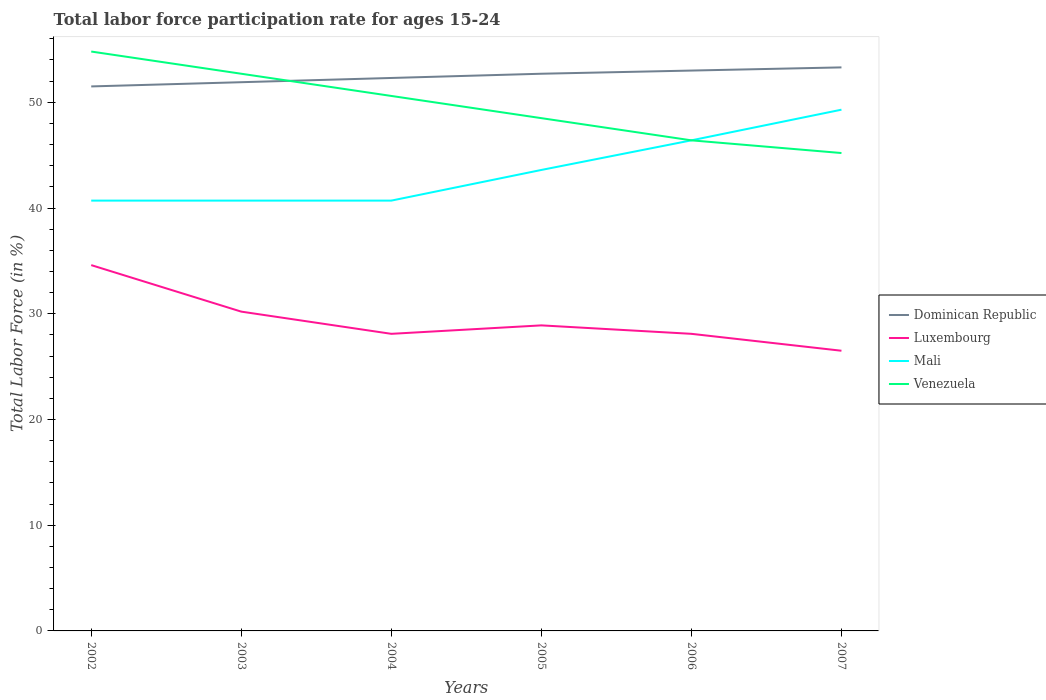Does the line corresponding to Luxembourg intersect with the line corresponding to Mali?
Make the answer very short. No. Across all years, what is the maximum labor force participation rate in Mali?
Offer a terse response. 40.7. In which year was the labor force participation rate in Mali maximum?
Offer a terse response. 2002. What is the total labor force participation rate in Dominican Republic in the graph?
Your response must be concise. -1.4. What is the difference between the highest and the second highest labor force participation rate in Dominican Republic?
Your response must be concise. 1.8. What is the difference between the highest and the lowest labor force participation rate in Mali?
Your answer should be compact. 3. How many lines are there?
Offer a very short reply. 4. How many years are there in the graph?
Offer a very short reply. 6. What is the difference between two consecutive major ticks on the Y-axis?
Your answer should be compact. 10. Are the values on the major ticks of Y-axis written in scientific E-notation?
Provide a succinct answer. No. Does the graph contain any zero values?
Offer a very short reply. No. Does the graph contain grids?
Give a very brief answer. No. Where does the legend appear in the graph?
Your response must be concise. Center right. How many legend labels are there?
Provide a succinct answer. 4. How are the legend labels stacked?
Give a very brief answer. Vertical. What is the title of the graph?
Your answer should be very brief. Total labor force participation rate for ages 15-24. Does "Uganda" appear as one of the legend labels in the graph?
Make the answer very short. No. What is the Total Labor Force (in %) of Dominican Republic in 2002?
Your answer should be compact. 51.5. What is the Total Labor Force (in %) in Luxembourg in 2002?
Your answer should be compact. 34.6. What is the Total Labor Force (in %) in Mali in 2002?
Give a very brief answer. 40.7. What is the Total Labor Force (in %) of Venezuela in 2002?
Offer a very short reply. 54.8. What is the Total Labor Force (in %) of Dominican Republic in 2003?
Provide a succinct answer. 51.9. What is the Total Labor Force (in %) in Luxembourg in 2003?
Offer a very short reply. 30.2. What is the Total Labor Force (in %) in Mali in 2003?
Ensure brevity in your answer.  40.7. What is the Total Labor Force (in %) in Venezuela in 2003?
Keep it short and to the point. 52.7. What is the Total Labor Force (in %) of Dominican Republic in 2004?
Make the answer very short. 52.3. What is the Total Labor Force (in %) in Luxembourg in 2004?
Your answer should be very brief. 28.1. What is the Total Labor Force (in %) in Mali in 2004?
Offer a terse response. 40.7. What is the Total Labor Force (in %) in Venezuela in 2004?
Give a very brief answer. 50.6. What is the Total Labor Force (in %) in Dominican Republic in 2005?
Your answer should be compact. 52.7. What is the Total Labor Force (in %) of Luxembourg in 2005?
Your response must be concise. 28.9. What is the Total Labor Force (in %) in Mali in 2005?
Your response must be concise. 43.6. What is the Total Labor Force (in %) of Venezuela in 2005?
Keep it short and to the point. 48.5. What is the Total Labor Force (in %) in Luxembourg in 2006?
Your answer should be very brief. 28.1. What is the Total Labor Force (in %) of Mali in 2006?
Make the answer very short. 46.4. What is the Total Labor Force (in %) of Venezuela in 2006?
Make the answer very short. 46.4. What is the Total Labor Force (in %) in Dominican Republic in 2007?
Your answer should be very brief. 53.3. What is the Total Labor Force (in %) of Luxembourg in 2007?
Provide a succinct answer. 26.5. What is the Total Labor Force (in %) in Mali in 2007?
Ensure brevity in your answer.  49.3. What is the Total Labor Force (in %) in Venezuela in 2007?
Keep it short and to the point. 45.2. Across all years, what is the maximum Total Labor Force (in %) in Dominican Republic?
Provide a succinct answer. 53.3. Across all years, what is the maximum Total Labor Force (in %) in Luxembourg?
Your answer should be very brief. 34.6. Across all years, what is the maximum Total Labor Force (in %) in Mali?
Provide a succinct answer. 49.3. Across all years, what is the maximum Total Labor Force (in %) in Venezuela?
Keep it short and to the point. 54.8. Across all years, what is the minimum Total Labor Force (in %) in Dominican Republic?
Give a very brief answer. 51.5. Across all years, what is the minimum Total Labor Force (in %) in Mali?
Your answer should be compact. 40.7. Across all years, what is the minimum Total Labor Force (in %) of Venezuela?
Make the answer very short. 45.2. What is the total Total Labor Force (in %) in Dominican Republic in the graph?
Keep it short and to the point. 314.7. What is the total Total Labor Force (in %) of Luxembourg in the graph?
Offer a terse response. 176.4. What is the total Total Labor Force (in %) of Mali in the graph?
Offer a very short reply. 261.4. What is the total Total Labor Force (in %) of Venezuela in the graph?
Provide a short and direct response. 298.2. What is the difference between the Total Labor Force (in %) in Dominican Republic in 2002 and that in 2003?
Your answer should be compact. -0.4. What is the difference between the Total Labor Force (in %) of Mali in 2002 and that in 2003?
Give a very brief answer. 0. What is the difference between the Total Labor Force (in %) of Venezuela in 2002 and that in 2003?
Provide a short and direct response. 2.1. What is the difference between the Total Labor Force (in %) in Luxembourg in 2002 and that in 2004?
Your answer should be very brief. 6.5. What is the difference between the Total Labor Force (in %) of Dominican Republic in 2002 and that in 2005?
Offer a very short reply. -1.2. What is the difference between the Total Labor Force (in %) in Luxembourg in 2002 and that in 2005?
Your answer should be very brief. 5.7. What is the difference between the Total Labor Force (in %) of Dominican Republic in 2002 and that in 2006?
Give a very brief answer. -1.5. What is the difference between the Total Labor Force (in %) in Luxembourg in 2002 and that in 2006?
Ensure brevity in your answer.  6.5. What is the difference between the Total Labor Force (in %) of Mali in 2002 and that in 2006?
Your answer should be compact. -5.7. What is the difference between the Total Labor Force (in %) in Luxembourg in 2002 and that in 2007?
Your answer should be compact. 8.1. What is the difference between the Total Labor Force (in %) in Mali in 2002 and that in 2007?
Your answer should be compact. -8.6. What is the difference between the Total Labor Force (in %) in Venezuela in 2002 and that in 2007?
Offer a very short reply. 9.6. What is the difference between the Total Labor Force (in %) of Luxembourg in 2003 and that in 2004?
Ensure brevity in your answer.  2.1. What is the difference between the Total Labor Force (in %) of Mali in 2003 and that in 2004?
Provide a short and direct response. 0. What is the difference between the Total Labor Force (in %) of Dominican Republic in 2003 and that in 2005?
Your response must be concise. -0.8. What is the difference between the Total Labor Force (in %) of Luxembourg in 2003 and that in 2005?
Give a very brief answer. 1.3. What is the difference between the Total Labor Force (in %) of Mali in 2003 and that in 2005?
Give a very brief answer. -2.9. What is the difference between the Total Labor Force (in %) in Dominican Republic in 2003 and that in 2006?
Provide a succinct answer. -1.1. What is the difference between the Total Labor Force (in %) of Mali in 2003 and that in 2006?
Provide a succinct answer. -5.7. What is the difference between the Total Labor Force (in %) of Venezuela in 2003 and that in 2006?
Make the answer very short. 6.3. What is the difference between the Total Labor Force (in %) in Dominican Republic in 2003 and that in 2007?
Your answer should be very brief. -1.4. What is the difference between the Total Labor Force (in %) of Mali in 2003 and that in 2007?
Provide a succinct answer. -8.6. What is the difference between the Total Labor Force (in %) of Venezuela in 2003 and that in 2007?
Keep it short and to the point. 7.5. What is the difference between the Total Labor Force (in %) in Dominican Republic in 2004 and that in 2005?
Provide a short and direct response. -0.4. What is the difference between the Total Labor Force (in %) of Mali in 2004 and that in 2005?
Your answer should be very brief. -2.9. What is the difference between the Total Labor Force (in %) in Dominican Republic in 2004 and that in 2006?
Make the answer very short. -0.7. What is the difference between the Total Labor Force (in %) in Mali in 2004 and that in 2006?
Provide a succinct answer. -5.7. What is the difference between the Total Labor Force (in %) of Venezuela in 2004 and that in 2006?
Make the answer very short. 4.2. What is the difference between the Total Labor Force (in %) in Dominican Republic in 2004 and that in 2007?
Your answer should be very brief. -1. What is the difference between the Total Labor Force (in %) in Dominican Republic in 2005 and that in 2006?
Offer a very short reply. -0.3. What is the difference between the Total Labor Force (in %) in Venezuela in 2005 and that in 2006?
Provide a succinct answer. 2.1. What is the difference between the Total Labor Force (in %) of Luxembourg in 2005 and that in 2007?
Your answer should be compact. 2.4. What is the difference between the Total Labor Force (in %) of Mali in 2005 and that in 2007?
Offer a very short reply. -5.7. What is the difference between the Total Labor Force (in %) of Dominican Republic in 2006 and that in 2007?
Provide a short and direct response. -0.3. What is the difference between the Total Labor Force (in %) of Mali in 2006 and that in 2007?
Offer a very short reply. -2.9. What is the difference between the Total Labor Force (in %) in Dominican Republic in 2002 and the Total Labor Force (in %) in Luxembourg in 2003?
Offer a very short reply. 21.3. What is the difference between the Total Labor Force (in %) of Dominican Republic in 2002 and the Total Labor Force (in %) of Mali in 2003?
Your answer should be compact. 10.8. What is the difference between the Total Labor Force (in %) in Luxembourg in 2002 and the Total Labor Force (in %) in Mali in 2003?
Make the answer very short. -6.1. What is the difference between the Total Labor Force (in %) of Luxembourg in 2002 and the Total Labor Force (in %) of Venezuela in 2003?
Your answer should be compact. -18.1. What is the difference between the Total Labor Force (in %) of Mali in 2002 and the Total Labor Force (in %) of Venezuela in 2003?
Offer a very short reply. -12. What is the difference between the Total Labor Force (in %) of Dominican Republic in 2002 and the Total Labor Force (in %) of Luxembourg in 2004?
Make the answer very short. 23.4. What is the difference between the Total Labor Force (in %) of Dominican Republic in 2002 and the Total Labor Force (in %) of Venezuela in 2004?
Your response must be concise. 0.9. What is the difference between the Total Labor Force (in %) of Dominican Republic in 2002 and the Total Labor Force (in %) of Luxembourg in 2005?
Your answer should be compact. 22.6. What is the difference between the Total Labor Force (in %) of Dominican Republic in 2002 and the Total Labor Force (in %) of Venezuela in 2005?
Your answer should be very brief. 3. What is the difference between the Total Labor Force (in %) in Luxembourg in 2002 and the Total Labor Force (in %) in Mali in 2005?
Keep it short and to the point. -9. What is the difference between the Total Labor Force (in %) in Luxembourg in 2002 and the Total Labor Force (in %) in Venezuela in 2005?
Your response must be concise. -13.9. What is the difference between the Total Labor Force (in %) of Mali in 2002 and the Total Labor Force (in %) of Venezuela in 2005?
Keep it short and to the point. -7.8. What is the difference between the Total Labor Force (in %) in Dominican Republic in 2002 and the Total Labor Force (in %) in Luxembourg in 2006?
Offer a very short reply. 23.4. What is the difference between the Total Labor Force (in %) of Dominican Republic in 2002 and the Total Labor Force (in %) of Mali in 2006?
Make the answer very short. 5.1. What is the difference between the Total Labor Force (in %) in Dominican Republic in 2002 and the Total Labor Force (in %) in Venezuela in 2006?
Your answer should be compact. 5.1. What is the difference between the Total Labor Force (in %) in Mali in 2002 and the Total Labor Force (in %) in Venezuela in 2006?
Your answer should be very brief. -5.7. What is the difference between the Total Labor Force (in %) in Luxembourg in 2002 and the Total Labor Force (in %) in Mali in 2007?
Your response must be concise. -14.7. What is the difference between the Total Labor Force (in %) of Luxembourg in 2002 and the Total Labor Force (in %) of Venezuela in 2007?
Offer a terse response. -10.6. What is the difference between the Total Labor Force (in %) of Mali in 2002 and the Total Labor Force (in %) of Venezuela in 2007?
Your answer should be very brief. -4.5. What is the difference between the Total Labor Force (in %) of Dominican Republic in 2003 and the Total Labor Force (in %) of Luxembourg in 2004?
Ensure brevity in your answer.  23.8. What is the difference between the Total Labor Force (in %) in Dominican Republic in 2003 and the Total Labor Force (in %) in Mali in 2004?
Your response must be concise. 11.2. What is the difference between the Total Labor Force (in %) of Luxembourg in 2003 and the Total Labor Force (in %) of Mali in 2004?
Offer a very short reply. -10.5. What is the difference between the Total Labor Force (in %) of Luxembourg in 2003 and the Total Labor Force (in %) of Venezuela in 2004?
Your answer should be compact. -20.4. What is the difference between the Total Labor Force (in %) in Mali in 2003 and the Total Labor Force (in %) in Venezuela in 2004?
Your answer should be compact. -9.9. What is the difference between the Total Labor Force (in %) in Dominican Republic in 2003 and the Total Labor Force (in %) in Mali in 2005?
Give a very brief answer. 8.3. What is the difference between the Total Labor Force (in %) in Luxembourg in 2003 and the Total Labor Force (in %) in Mali in 2005?
Give a very brief answer. -13.4. What is the difference between the Total Labor Force (in %) of Luxembourg in 2003 and the Total Labor Force (in %) of Venezuela in 2005?
Ensure brevity in your answer.  -18.3. What is the difference between the Total Labor Force (in %) of Mali in 2003 and the Total Labor Force (in %) of Venezuela in 2005?
Give a very brief answer. -7.8. What is the difference between the Total Labor Force (in %) of Dominican Republic in 2003 and the Total Labor Force (in %) of Luxembourg in 2006?
Provide a short and direct response. 23.8. What is the difference between the Total Labor Force (in %) of Dominican Republic in 2003 and the Total Labor Force (in %) of Mali in 2006?
Provide a short and direct response. 5.5. What is the difference between the Total Labor Force (in %) in Luxembourg in 2003 and the Total Labor Force (in %) in Mali in 2006?
Make the answer very short. -16.2. What is the difference between the Total Labor Force (in %) of Luxembourg in 2003 and the Total Labor Force (in %) of Venezuela in 2006?
Your answer should be compact. -16.2. What is the difference between the Total Labor Force (in %) in Dominican Republic in 2003 and the Total Labor Force (in %) in Luxembourg in 2007?
Give a very brief answer. 25.4. What is the difference between the Total Labor Force (in %) in Dominican Republic in 2003 and the Total Labor Force (in %) in Venezuela in 2007?
Provide a short and direct response. 6.7. What is the difference between the Total Labor Force (in %) of Luxembourg in 2003 and the Total Labor Force (in %) of Mali in 2007?
Provide a succinct answer. -19.1. What is the difference between the Total Labor Force (in %) in Luxembourg in 2003 and the Total Labor Force (in %) in Venezuela in 2007?
Give a very brief answer. -15. What is the difference between the Total Labor Force (in %) of Mali in 2003 and the Total Labor Force (in %) of Venezuela in 2007?
Your response must be concise. -4.5. What is the difference between the Total Labor Force (in %) in Dominican Republic in 2004 and the Total Labor Force (in %) in Luxembourg in 2005?
Provide a succinct answer. 23.4. What is the difference between the Total Labor Force (in %) of Dominican Republic in 2004 and the Total Labor Force (in %) of Mali in 2005?
Your answer should be very brief. 8.7. What is the difference between the Total Labor Force (in %) of Luxembourg in 2004 and the Total Labor Force (in %) of Mali in 2005?
Keep it short and to the point. -15.5. What is the difference between the Total Labor Force (in %) of Luxembourg in 2004 and the Total Labor Force (in %) of Venezuela in 2005?
Make the answer very short. -20.4. What is the difference between the Total Labor Force (in %) of Dominican Republic in 2004 and the Total Labor Force (in %) of Luxembourg in 2006?
Your response must be concise. 24.2. What is the difference between the Total Labor Force (in %) in Dominican Republic in 2004 and the Total Labor Force (in %) in Mali in 2006?
Offer a terse response. 5.9. What is the difference between the Total Labor Force (in %) in Dominican Republic in 2004 and the Total Labor Force (in %) in Venezuela in 2006?
Your response must be concise. 5.9. What is the difference between the Total Labor Force (in %) of Luxembourg in 2004 and the Total Labor Force (in %) of Mali in 2006?
Your answer should be very brief. -18.3. What is the difference between the Total Labor Force (in %) in Luxembourg in 2004 and the Total Labor Force (in %) in Venezuela in 2006?
Offer a terse response. -18.3. What is the difference between the Total Labor Force (in %) of Dominican Republic in 2004 and the Total Labor Force (in %) of Luxembourg in 2007?
Offer a very short reply. 25.8. What is the difference between the Total Labor Force (in %) of Dominican Republic in 2004 and the Total Labor Force (in %) of Mali in 2007?
Provide a short and direct response. 3. What is the difference between the Total Labor Force (in %) of Dominican Republic in 2004 and the Total Labor Force (in %) of Venezuela in 2007?
Provide a short and direct response. 7.1. What is the difference between the Total Labor Force (in %) in Luxembourg in 2004 and the Total Labor Force (in %) in Mali in 2007?
Offer a terse response. -21.2. What is the difference between the Total Labor Force (in %) of Luxembourg in 2004 and the Total Labor Force (in %) of Venezuela in 2007?
Your answer should be compact. -17.1. What is the difference between the Total Labor Force (in %) in Mali in 2004 and the Total Labor Force (in %) in Venezuela in 2007?
Your answer should be compact. -4.5. What is the difference between the Total Labor Force (in %) of Dominican Republic in 2005 and the Total Labor Force (in %) of Luxembourg in 2006?
Make the answer very short. 24.6. What is the difference between the Total Labor Force (in %) of Dominican Republic in 2005 and the Total Labor Force (in %) of Mali in 2006?
Ensure brevity in your answer.  6.3. What is the difference between the Total Labor Force (in %) in Dominican Republic in 2005 and the Total Labor Force (in %) in Venezuela in 2006?
Ensure brevity in your answer.  6.3. What is the difference between the Total Labor Force (in %) of Luxembourg in 2005 and the Total Labor Force (in %) of Mali in 2006?
Your answer should be compact. -17.5. What is the difference between the Total Labor Force (in %) in Luxembourg in 2005 and the Total Labor Force (in %) in Venezuela in 2006?
Offer a very short reply. -17.5. What is the difference between the Total Labor Force (in %) of Dominican Republic in 2005 and the Total Labor Force (in %) of Luxembourg in 2007?
Your response must be concise. 26.2. What is the difference between the Total Labor Force (in %) of Luxembourg in 2005 and the Total Labor Force (in %) of Mali in 2007?
Your answer should be very brief. -20.4. What is the difference between the Total Labor Force (in %) of Luxembourg in 2005 and the Total Labor Force (in %) of Venezuela in 2007?
Provide a succinct answer. -16.3. What is the difference between the Total Labor Force (in %) of Dominican Republic in 2006 and the Total Labor Force (in %) of Venezuela in 2007?
Your answer should be compact. 7.8. What is the difference between the Total Labor Force (in %) in Luxembourg in 2006 and the Total Labor Force (in %) in Mali in 2007?
Your answer should be very brief. -21.2. What is the difference between the Total Labor Force (in %) of Luxembourg in 2006 and the Total Labor Force (in %) of Venezuela in 2007?
Offer a terse response. -17.1. What is the average Total Labor Force (in %) of Dominican Republic per year?
Give a very brief answer. 52.45. What is the average Total Labor Force (in %) of Luxembourg per year?
Your answer should be compact. 29.4. What is the average Total Labor Force (in %) of Mali per year?
Offer a terse response. 43.57. What is the average Total Labor Force (in %) in Venezuela per year?
Your answer should be compact. 49.7. In the year 2002, what is the difference between the Total Labor Force (in %) of Dominican Republic and Total Labor Force (in %) of Mali?
Offer a very short reply. 10.8. In the year 2002, what is the difference between the Total Labor Force (in %) of Dominican Republic and Total Labor Force (in %) of Venezuela?
Your answer should be compact. -3.3. In the year 2002, what is the difference between the Total Labor Force (in %) in Luxembourg and Total Labor Force (in %) in Venezuela?
Provide a short and direct response. -20.2. In the year 2002, what is the difference between the Total Labor Force (in %) of Mali and Total Labor Force (in %) of Venezuela?
Offer a terse response. -14.1. In the year 2003, what is the difference between the Total Labor Force (in %) in Dominican Republic and Total Labor Force (in %) in Luxembourg?
Ensure brevity in your answer.  21.7. In the year 2003, what is the difference between the Total Labor Force (in %) of Dominican Republic and Total Labor Force (in %) of Mali?
Your response must be concise. 11.2. In the year 2003, what is the difference between the Total Labor Force (in %) of Luxembourg and Total Labor Force (in %) of Venezuela?
Your answer should be compact. -22.5. In the year 2004, what is the difference between the Total Labor Force (in %) of Dominican Republic and Total Labor Force (in %) of Luxembourg?
Offer a very short reply. 24.2. In the year 2004, what is the difference between the Total Labor Force (in %) of Dominican Republic and Total Labor Force (in %) of Mali?
Ensure brevity in your answer.  11.6. In the year 2004, what is the difference between the Total Labor Force (in %) in Luxembourg and Total Labor Force (in %) in Mali?
Give a very brief answer. -12.6. In the year 2004, what is the difference between the Total Labor Force (in %) in Luxembourg and Total Labor Force (in %) in Venezuela?
Keep it short and to the point. -22.5. In the year 2005, what is the difference between the Total Labor Force (in %) in Dominican Republic and Total Labor Force (in %) in Luxembourg?
Keep it short and to the point. 23.8. In the year 2005, what is the difference between the Total Labor Force (in %) of Dominican Republic and Total Labor Force (in %) of Mali?
Keep it short and to the point. 9.1. In the year 2005, what is the difference between the Total Labor Force (in %) of Luxembourg and Total Labor Force (in %) of Mali?
Offer a terse response. -14.7. In the year 2005, what is the difference between the Total Labor Force (in %) in Luxembourg and Total Labor Force (in %) in Venezuela?
Ensure brevity in your answer.  -19.6. In the year 2006, what is the difference between the Total Labor Force (in %) in Dominican Republic and Total Labor Force (in %) in Luxembourg?
Offer a terse response. 24.9. In the year 2006, what is the difference between the Total Labor Force (in %) of Luxembourg and Total Labor Force (in %) of Mali?
Offer a terse response. -18.3. In the year 2006, what is the difference between the Total Labor Force (in %) of Luxembourg and Total Labor Force (in %) of Venezuela?
Provide a succinct answer. -18.3. In the year 2007, what is the difference between the Total Labor Force (in %) of Dominican Republic and Total Labor Force (in %) of Luxembourg?
Your answer should be very brief. 26.8. In the year 2007, what is the difference between the Total Labor Force (in %) in Dominican Republic and Total Labor Force (in %) in Mali?
Your answer should be compact. 4. In the year 2007, what is the difference between the Total Labor Force (in %) in Dominican Republic and Total Labor Force (in %) in Venezuela?
Give a very brief answer. 8.1. In the year 2007, what is the difference between the Total Labor Force (in %) in Luxembourg and Total Labor Force (in %) in Mali?
Provide a succinct answer. -22.8. In the year 2007, what is the difference between the Total Labor Force (in %) in Luxembourg and Total Labor Force (in %) in Venezuela?
Your answer should be very brief. -18.7. What is the ratio of the Total Labor Force (in %) in Dominican Republic in 2002 to that in 2003?
Offer a very short reply. 0.99. What is the ratio of the Total Labor Force (in %) in Luxembourg in 2002 to that in 2003?
Your answer should be compact. 1.15. What is the ratio of the Total Labor Force (in %) of Venezuela in 2002 to that in 2003?
Your answer should be compact. 1.04. What is the ratio of the Total Labor Force (in %) in Dominican Republic in 2002 to that in 2004?
Provide a succinct answer. 0.98. What is the ratio of the Total Labor Force (in %) in Luxembourg in 2002 to that in 2004?
Offer a very short reply. 1.23. What is the ratio of the Total Labor Force (in %) in Mali in 2002 to that in 2004?
Ensure brevity in your answer.  1. What is the ratio of the Total Labor Force (in %) of Venezuela in 2002 to that in 2004?
Offer a terse response. 1.08. What is the ratio of the Total Labor Force (in %) in Dominican Republic in 2002 to that in 2005?
Offer a very short reply. 0.98. What is the ratio of the Total Labor Force (in %) of Luxembourg in 2002 to that in 2005?
Provide a short and direct response. 1.2. What is the ratio of the Total Labor Force (in %) in Mali in 2002 to that in 2005?
Keep it short and to the point. 0.93. What is the ratio of the Total Labor Force (in %) in Venezuela in 2002 to that in 2005?
Provide a short and direct response. 1.13. What is the ratio of the Total Labor Force (in %) of Dominican Republic in 2002 to that in 2006?
Provide a short and direct response. 0.97. What is the ratio of the Total Labor Force (in %) in Luxembourg in 2002 to that in 2006?
Your answer should be very brief. 1.23. What is the ratio of the Total Labor Force (in %) in Mali in 2002 to that in 2006?
Offer a terse response. 0.88. What is the ratio of the Total Labor Force (in %) of Venezuela in 2002 to that in 2006?
Make the answer very short. 1.18. What is the ratio of the Total Labor Force (in %) in Dominican Republic in 2002 to that in 2007?
Ensure brevity in your answer.  0.97. What is the ratio of the Total Labor Force (in %) in Luxembourg in 2002 to that in 2007?
Provide a succinct answer. 1.31. What is the ratio of the Total Labor Force (in %) in Mali in 2002 to that in 2007?
Offer a very short reply. 0.83. What is the ratio of the Total Labor Force (in %) in Venezuela in 2002 to that in 2007?
Provide a succinct answer. 1.21. What is the ratio of the Total Labor Force (in %) of Dominican Republic in 2003 to that in 2004?
Offer a very short reply. 0.99. What is the ratio of the Total Labor Force (in %) of Luxembourg in 2003 to that in 2004?
Your response must be concise. 1.07. What is the ratio of the Total Labor Force (in %) in Mali in 2003 to that in 2004?
Offer a very short reply. 1. What is the ratio of the Total Labor Force (in %) in Venezuela in 2003 to that in 2004?
Give a very brief answer. 1.04. What is the ratio of the Total Labor Force (in %) of Dominican Republic in 2003 to that in 2005?
Ensure brevity in your answer.  0.98. What is the ratio of the Total Labor Force (in %) of Luxembourg in 2003 to that in 2005?
Provide a succinct answer. 1.04. What is the ratio of the Total Labor Force (in %) in Mali in 2003 to that in 2005?
Ensure brevity in your answer.  0.93. What is the ratio of the Total Labor Force (in %) in Venezuela in 2003 to that in 2005?
Your answer should be compact. 1.09. What is the ratio of the Total Labor Force (in %) of Dominican Republic in 2003 to that in 2006?
Provide a short and direct response. 0.98. What is the ratio of the Total Labor Force (in %) of Luxembourg in 2003 to that in 2006?
Ensure brevity in your answer.  1.07. What is the ratio of the Total Labor Force (in %) in Mali in 2003 to that in 2006?
Give a very brief answer. 0.88. What is the ratio of the Total Labor Force (in %) of Venezuela in 2003 to that in 2006?
Your answer should be compact. 1.14. What is the ratio of the Total Labor Force (in %) in Dominican Republic in 2003 to that in 2007?
Keep it short and to the point. 0.97. What is the ratio of the Total Labor Force (in %) in Luxembourg in 2003 to that in 2007?
Your answer should be very brief. 1.14. What is the ratio of the Total Labor Force (in %) in Mali in 2003 to that in 2007?
Ensure brevity in your answer.  0.83. What is the ratio of the Total Labor Force (in %) in Venezuela in 2003 to that in 2007?
Your response must be concise. 1.17. What is the ratio of the Total Labor Force (in %) of Luxembourg in 2004 to that in 2005?
Ensure brevity in your answer.  0.97. What is the ratio of the Total Labor Force (in %) in Mali in 2004 to that in 2005?
Provide a short and direct response. 0.93. What is the ratio of the Total Labor Force (in %) in Venezuela in 2004 to that in 2005?
Provide a short and direct response. 1.04. What is the ratio of the Total Labor Force (in %) of Luxembourg in 2004 to that in 2006?
Your answer should be compact. 1. What is the ratio of the Total Labor Force (in %) of Mali in 2004 to that in 2006?
Ensure brevity in your answer.  0.88. What is the ratio of the Total Labor Force (in %) in Venezuela in 2004 to that in 2006?
Give a very brief answer. 1.09. What is the ratio of the Total Labor Force (in %) in Dominican Republic in 2004 to that in 2007?
Your answer should be compact. 0.98. What is the ratio of the Total Labor Force (in %) in Luxembourg in 2004 to that in 2007?
Keep it short and to the point. 1.06. What is the ratio of the Total Labor Force (in %) of Mali in 2004 to that in 2007?
Keep it short and to the point. 0.83. What is the ratio of the Total Labor Force (in %) in Venezuela in 2004 to that in 2007?
Your response must be concise. 1.12. What is the ratio of the Total Labor Force (in %) of Dominican Republic in 2005 to that in 2006?
Provide a succinct answer. 0.99. What is the ratio of the Total Labor Force (in %) in Luxembourg in 2005 to that in 2006?
Provide a short and direct response. 1.03. What is the ratio of the Total Labor Force (in %) of Mali in 2005 to that in 2006?
Offer a very short reply. 0.94. What is the ratio of the Total Labor Force (in %) in Venezuela in 2005 to that in 2006?
Ensure brevity in your answer.  1.05. What is the ratio of the Total Labor Force (in %) in Dominican Republic in 2005 to that in 2007?
Provide a succinct answer. 0.99. What is the ratio of the Total Labor Force (in %) in Luxembourg in 2005 to that in 2007?
Your answer should be compact. 1.09. What is the ratio of the Total Labor Force (in %) in Mali in 2005 to that in 2007?
Your answer should be compact. 0.88. What is the ratio of the Total Labor Force (in %) in Venezuela in 2005 to that in 2007?
Keep it short and to the point. 1.07. What is the ratio of the Total Labor Force (in %) of Dominican Republic in 2006 to that in 2007?
Your answer should be very brief. 0.99. What is the ratio of the Total Labor Force (in %) in Luxembourg in 2006 to that in 2007?
Provide a succinct answer. 1.06. What is the ratio of the Total Labor Force (in %) of Venezuela in 2006 to that in 2007?
Your answer should be very brief. 1.03. What is the difference between the highest and the second highest Total Labor Force (in %) of Dominican Republic?
Keep it short and to the point. 0.3. What is the difference between the highest and the second highest Total Labor Force (in %) of Mali?
Your response must be concise. 2.9. What is the difference between the highest and the second highest Total Labor Force (in %) of Venezuela?
Keep it short and to the point. 2.1. What is the difference between the highest and the lowest Total Labor Force (in %) in Dominican Republic?
Give a very brief answer. 1.8. What is the difference between the highest and the lowest Total Labor Force (in %) in Mali?
Make the answer very short. 8.6. What is the difference between the highest and the lowest Total Labor Force (in %) in Venezuela?
Your response must be concise. 9.6. 